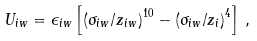<formula> <loc_0><loc_0><loc_500><loc_500>U _ { i w } = \epsilon _ { i w } \left [ \left ( { \sigma _ { i w } } / { z _ { i w } } \right ) ^ { 1 0 } - \left ( { \sigma _ { i w } } / { z _ { i } } \right ) ^ { 4 } \right ] \, ,</formula> 